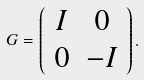<formula> <loc_0><loc_0><loc_500><loc_500>G = \left ( \begin{array} { c c } I & 0 \\ 0 & - I \end{array} \right ) .</formula> 